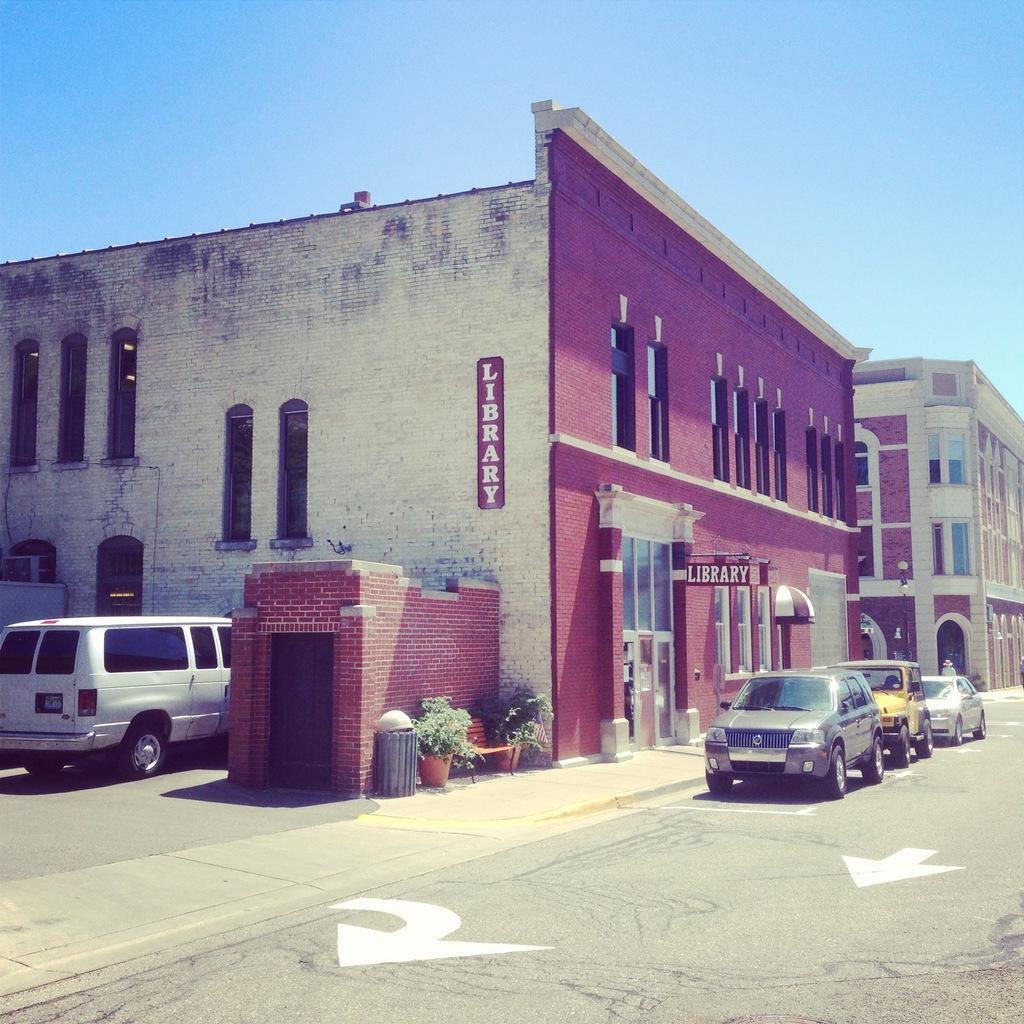How would you summarize this image in a sentence or two? As we can see in the image there are buildings, windows, vehicles, plants, pots and at the top there is sky. 